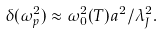<formula> <loc_0><loc_0><loc_500><loc_500>\delta ( \omega _ { p } ^ { 2 } ) \approx \omega _ { 0 } ^ { 2 } ( T ) a ^ { 2 } / \lambda _ { J } ^ { 2 } .</formula> 